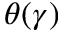<formula> <loc_0><loc_0><loc_500><loc_500>\theta ( \gamma )</formula> 